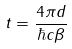<formula> <loc_0><loc_0><loc_500><loc_500>t = \frac { 4 \pi d } { \hbar { c } \beta }</formula> 